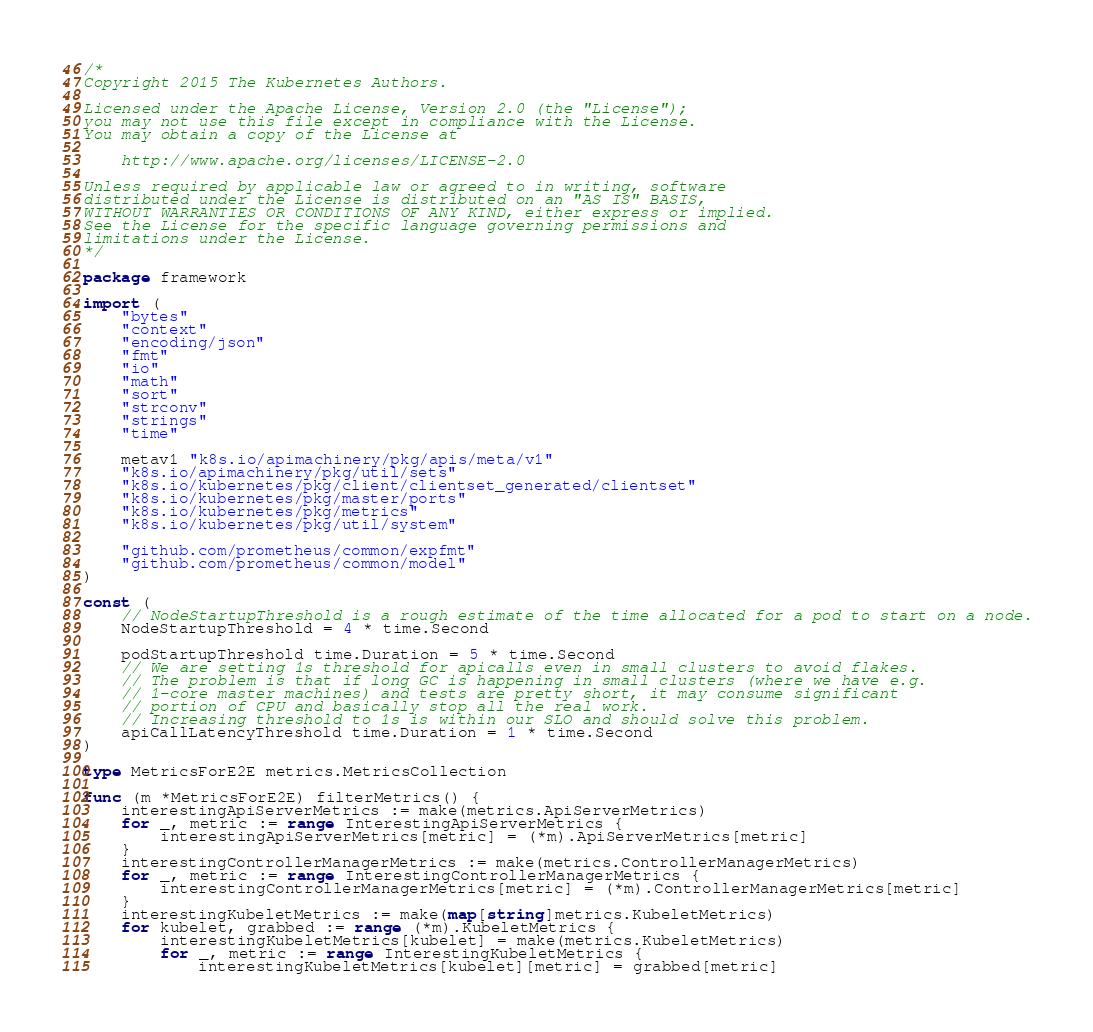Convert code to text. <code><loc_0><loc_0><loc_500><loc_500><_Go_>/*
Copyright 2015 The Kubernetes Authors.

Licensed under the Apache License, Version 2.0 (the "License");
you may not use this file except in compliance with the License.
You may obtain a copy of the License at

    http://www.apache.org/licenses/LICENSE-2.0

Unless required by applicable law or agreed to in writing, software
distributed under the License is distributed on an "AS IS" BASIS,
WITHOUT WARRANTIES OR CONDITIONS OF ANY KIND, either express or implied.
See the License for the specific language governing permissions and
limitations under the License.
*/

package framework

import (
	"bytes"
	"context"
	"encoding/json"
	"fmt"
	"io"
	"math"
	"sort"
	"strconv"
	"strings"
	"time"

	metav1 "k8s.io/apimachinery/pkg/apis/meta/v1"
	"k8s.io/apimachinery/pkg/util/sets"
	"k8s.io/kubernetes/pkg/client/clientset_generated/clientset"
	"k8s.io/kubernetes/pkg/master/ports"
	"k8s.io/kubernetes/pkg/metrics"
	"k8s.io/kubernetes/pkg/util/system"

	"github.com/prometheus/common/expfmt"
	"github.com/prometheus/common/model"
)

const (
	// NodeStartupThreshold is a rough estimate of the time allocated for a pod to start on a node.
	NodeStartupThreshold = 4 * time.Second

	podStartupThreshold time.Duration = 5 * time.Second
	// We are setting 1s threshold for apicalls even in small clusters to avoid flakes.
	// The problem is that if long GC is happening in small clusters (where we have e.g.
	// 1-core master machines) and tests are pretty short, it may consume significant
	// portion of CPU and basically stop all the real work.
	// Increasing threshold to 1s is within our SLO and should solve this problem.
	apiCallLatencyThreshold time.Duration = 1 * time.Second
)

type MetricsForE2E metrics.MetricsCollection

func (m *MetricsForE2E) filterMetrics() {
	interestingApiServerMetrics := make(metrics.ApiServerMetrics)
	for _, metric := range InterestingApiServerMetrics {
		interestingApiServerMetrics[metric] = (*m).ApiServerMetrics[metric]
	}
	interestingControllerManagerMetrics := make(metrics.ControllerManagerMetrics)
	for _, metric := range InterestingControllerManagerMetrics {
		interestingControllerManagerMetrics[metric] = (*m).ControllerManagerMetrics[metric]
	}
	interestingKubeletMetrics := make(map[string]metrics.KubeletMetrics)
	for kubelet, grabbed := range (*m).KubeletMetrics {
		interestingKubeletMetrics[kubelet] = make(metrics.KubeletMetrics)
		for _, metric := range InterestingKubeletMetrics {
			interestingKubeletMetrics[kubelet][metric] = grabbed[metric]</code> 